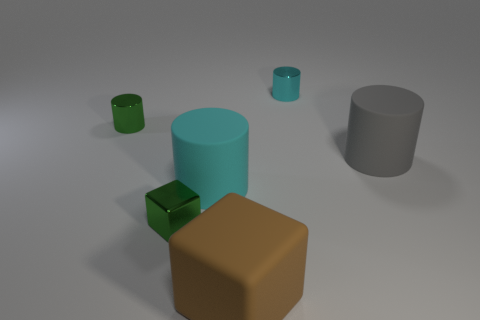Subtract all red cubes. How many cyan cylinders are left? 2 Subtract all tiny cyan shiny cylinders. How many cylinders are left? 3 Add 2 green shiny blocks. How many objects exist? 8 Subtract all green cylinders. How many cylinders are left? 3 Add 5 green things. How many green things exist? 7 Subtract 0 yellow cylinders. How many objects are left? 6 Subtract all cylinders. How many objects are left? 2 Subtract all purple cylinders. Subtract all green cubes. How many cylinders are left? 4 Subtract all cyan matte cylinders. Subtract all green metal things. How many objects are left? 3 Add 4 big cubes. How many big cubes are left? 5 